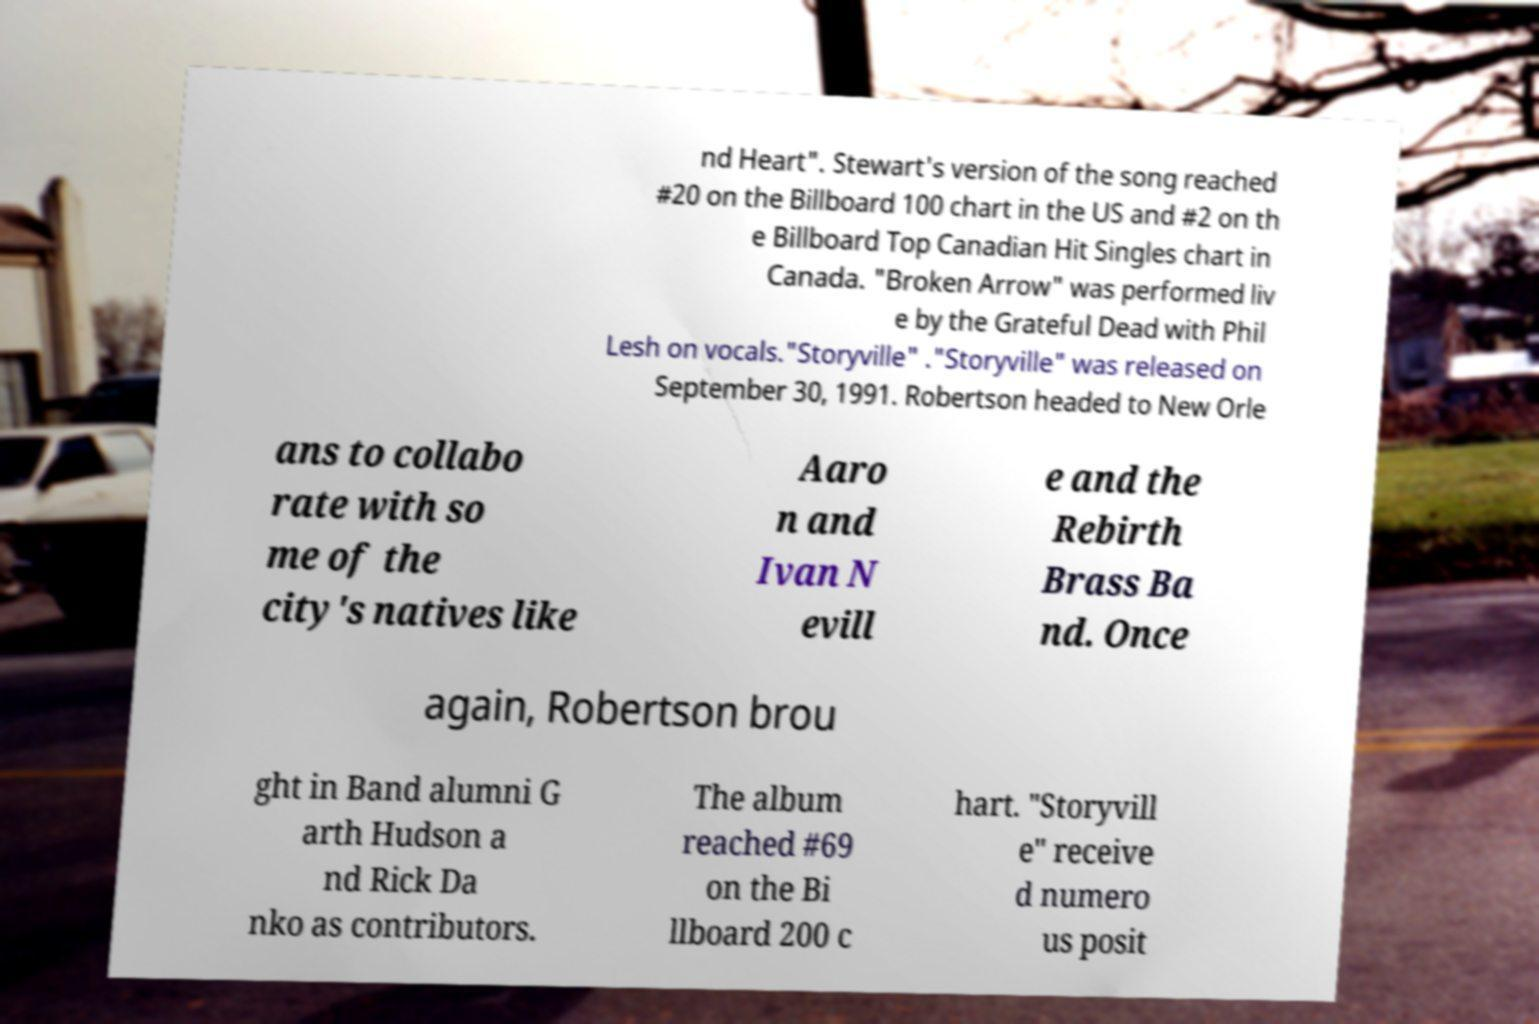For documentation purposes, I need the text within this image transcribed. Could you provide that? nd Heart". Stewart's version of the song reached #20 on the Billboard 100 chart in the US and #2 on th e Billboard Top Canadian Hit Singles chart in Canada. "Broken Arrow" was performed liv e by the Grateful Dead with Phil Lesh on vocals."Storyville" ."Storyville" was released on September 30, 1991. Robertson headed to New Orle ans to collabo rate with so me of the city's natives like Aaro n and Ivan N evill e and the Rebirth Brass Ba nd. Once again, Robertson brou ght in Band alumni G arth Hudson a nd Rick Da nko as contributors. The album reached #69 on the Bi llboard 200 c hart. "Storyvill e" receive d numero us posit 